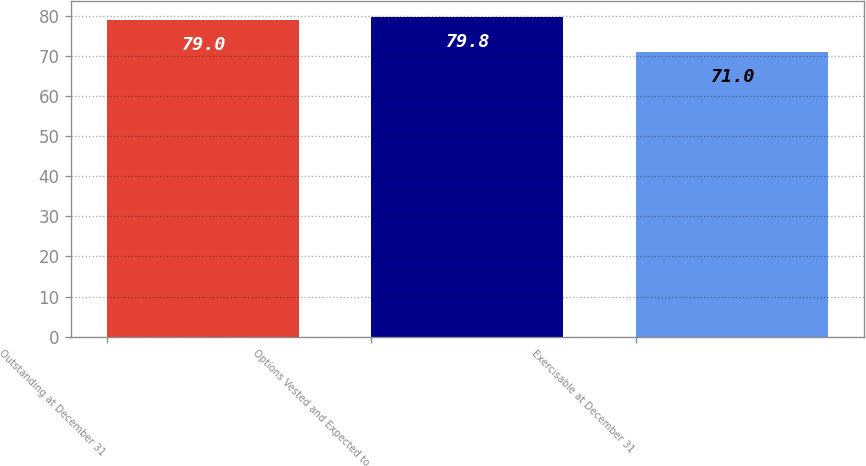Convert chart to OTSL. <chart><loc_0><loc_0><loc_500><loc_500><bar_chart><fcel>Outstanding at December 31<fcel>Options Vested and Expected to<fcel>Exercisable at December 31<nl><fcel>79<fcel>79.8<fcel>71<nl></chart> 